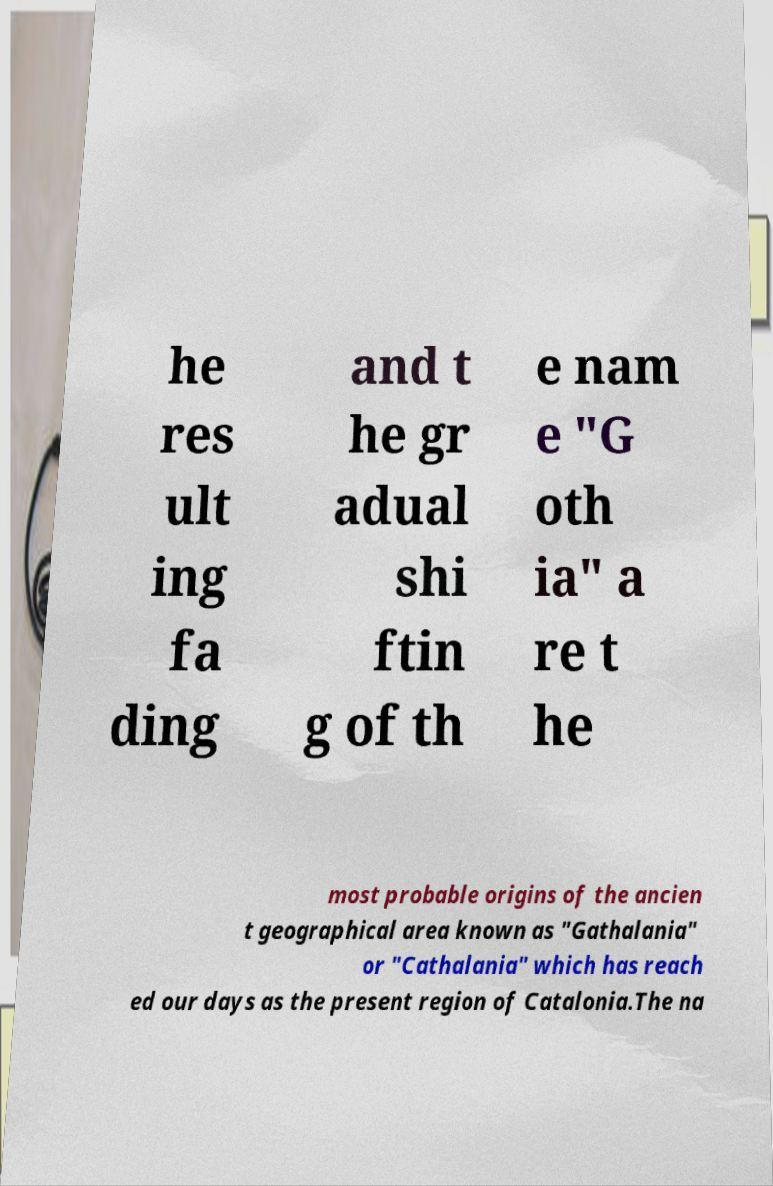Could you assist in decoding the text presented in this image and type it out clearly? he res ult ing fa ding and t he gr adual shi ftin g of th e nam e "G oth ia" a re t he most probable origins of the ancien t geographical area known as "Gathalania" or "Cathalania" which has reach ed our days as the present region of Catalonia.The na 